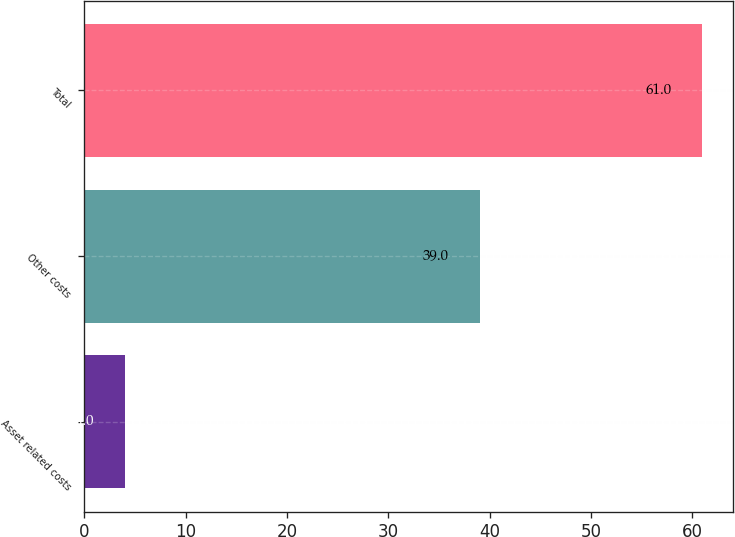<chart> <loc_0><loc_0><loc_500><loc_500><bar_chart><fcel>Asset related costs<fcel>Other costs<fcel>Total<nl><fcel>4<fcel>39<fcel>61<nl></chart> 